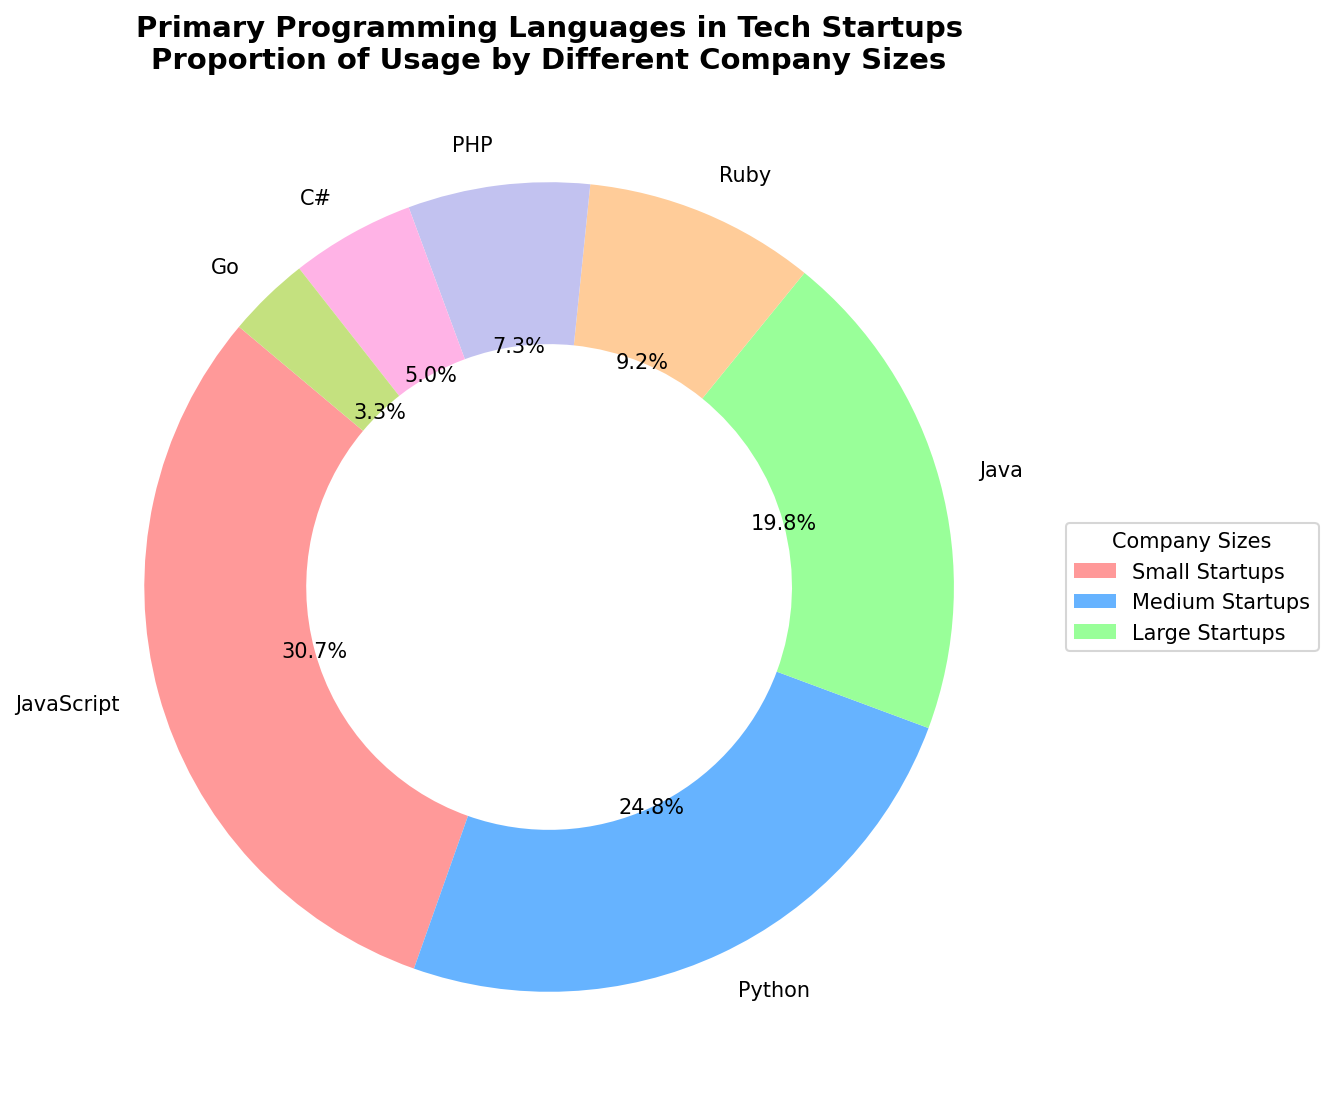What is the most popular programming language among small startups (1-50 employees)? Referring to the figure, we see that the largest wedge within the ring for small startups is associated with JavaScript. Hence, the most popular programming language for small startups is JavaScript.
Answer: JavaScript Which programming language shows a consistent trend of increasing usage from small to large startups? Looking at the proportion of usage for each language across the three company sizes, Java shows an increasing trend. It starts at 15% for small startups, increases to 20% in medium startups, and then up to 25% in large startups.
Answer: Java Among the languages, which one has the smallest slice in the chart for small startups and what is its percentage? The smallest slice for small startups is distinctively smaller compared to others and belongs to Go with a usage percentage of 2%.
Answer: Go, 2% How does the usage of Python compare between medium and large startups? Observing the figure, Python usage in medium startups is represented by a thinner wedge compared to its usage in large startups. Python in medium startups is 25%, whereas in large startups is 20%, showing a decreasing trend.
Answer: Python usage is higher in medium startups (25%) than in large startups (20%) Which company size shows the highest usage for Ruby and what is its proportion? Ruby usage is represented by identical wedge sizes in small and medium startups (10%) and decreases in large startups (8%). The highest usage is therefore observed in small and medium startups, both at 10%.
Answer: Small and medium startups, 10% 